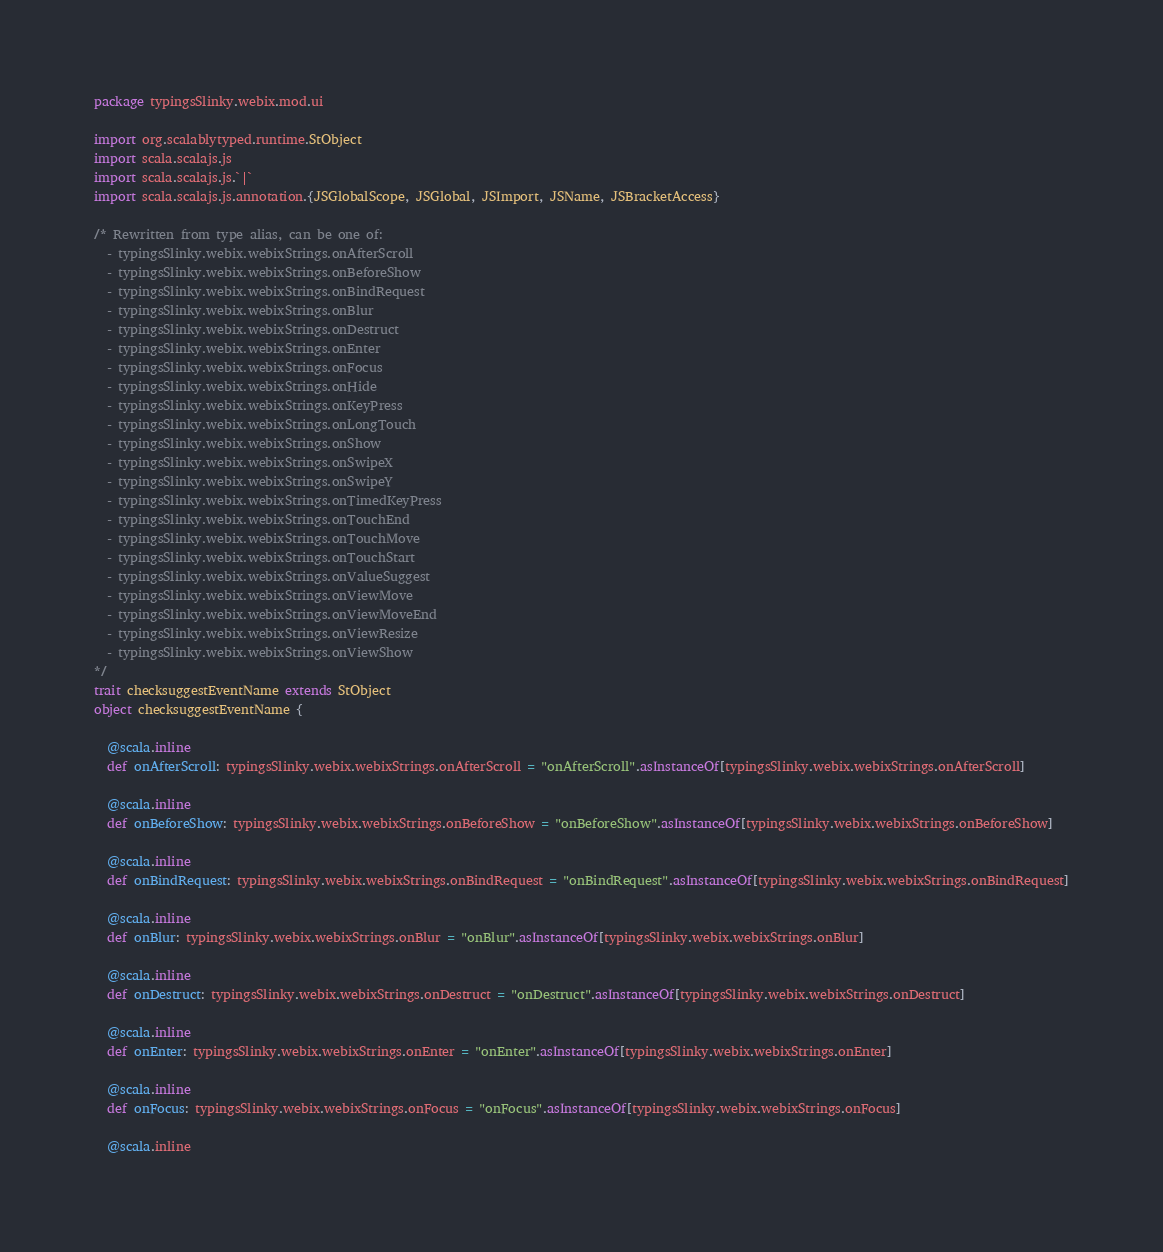Convert code to text. <code><loc_0><loc_0><loc_500><loc_500><_Scala_>package typingsSlinky.webix.mod.ui

import org.scalablytyped.runtime.StObject
import scala.scalajs.js
import scala.scalajs.js.`|`
import scala.scalajs.js.annotation.{JSGlobalScope, JSGlobal, JSImport, JSName, JSBracketAccess}

/* Rewritten from type alias, can be one of: 
  - typingsSlinky.webix.webixStrings.onAfterScroll
  - typingsSlinky.webix.webixStrings.onBeforeShow
  - typingsSlinky.webix.webixStrings.onBindRequest
  - typingsSlinky.webix.webixStrings.onBlur
  - typingsSlinky.webix.webixStrings.onDestruct
  - typingsSlinky.webix.webixStrings.onEnter
  - typingsSlinky.webix.webixStrings.onFocus
  - typingsSlinky.webix.webixStrings.onHide
  - typingsSlinky.webix.webixStrings.onKeyPress
  - typingsSlinky.webix.webixStrings.onLongTouch
  - typingsSlinky.webix.webixStrings.onShow
  - typingsSlinky.webix.webixStrings.onSwipeX
  - typingsSlinky.webix.webixStrings.onSwipeY
  - typingsSlinky.webix.webixStrings.onTimedKeyPress
  - typingsSlinky.webix.webixStrings.onTouchEnd
  - typingsSlinky.webix.webixStrings.onTouchMove
  - typingsSlinky.webix.webixStrings.onTouchStart
  - typingsSlinky.webix.webixStrings.onValueSuggest
  - typingsSlinky.webix.webixStrings.onViewMove
  - typingsSlinky.webix.webixStrings.onViewMoveEnd
  - typingsSlinky.webix.webixStrings.onViewResize
  - typingsSlinky.webix.webixStrings.onViewShow
*/
trait checksuggestEventName extends StObject
object checksuggestEventName {
  
  @scala.inline
  def onAfterScroll: typingsSlinky.webix.webixStrings.onAfterScroll = "onAfterScroll".asInstanceOf[typingsSlinky.webix.webixStrings.onAfterScroll]
  
  @scala.inline
  def onBeforeShow: typingsSlinky.webix.webixStrings.onBeforeShow = "onBeforeShow".asInstanceOf[typingsSlinky.webix.webixStrings.onBeforeShow]
  
  @scala.inline
  def onBindRequest: typingsSlinky.webix.webixStrings.onBindRequest = "onBindRequest".asInstanceOf[typingsSlinky.webix.webixStrings.onBindRequest]
  
  @scala.inline
  def onBlur: typingsSlinky.webix.webixStrings.onBlur = "onBlur".asInstanceOf[typingsSlinky.webix.webixStrings.onBlur]
  
  @scala.inline
  def onDestruct: typingsSlinky.webix.webixStrings.onDestruct = "onDestruct".asInstanceOf[typingsSlinky.webix.webixStrings.onDestruct]
  
  @scala.inline
  def onEnter: typingsSlinky.webix.webixStrings.onEnter = "onEnter".asInstanceOf[typingsSlinky.webix.webixStrings.onEnter]
  
  @scala.inline
  def onFocus: typingsSlinky.webix.webixStrings.onFocus = "onFocus".asInstanceOf[typingsSlinky.webix.webixStrings.onFocus]
  
  @scala.inline</code> 